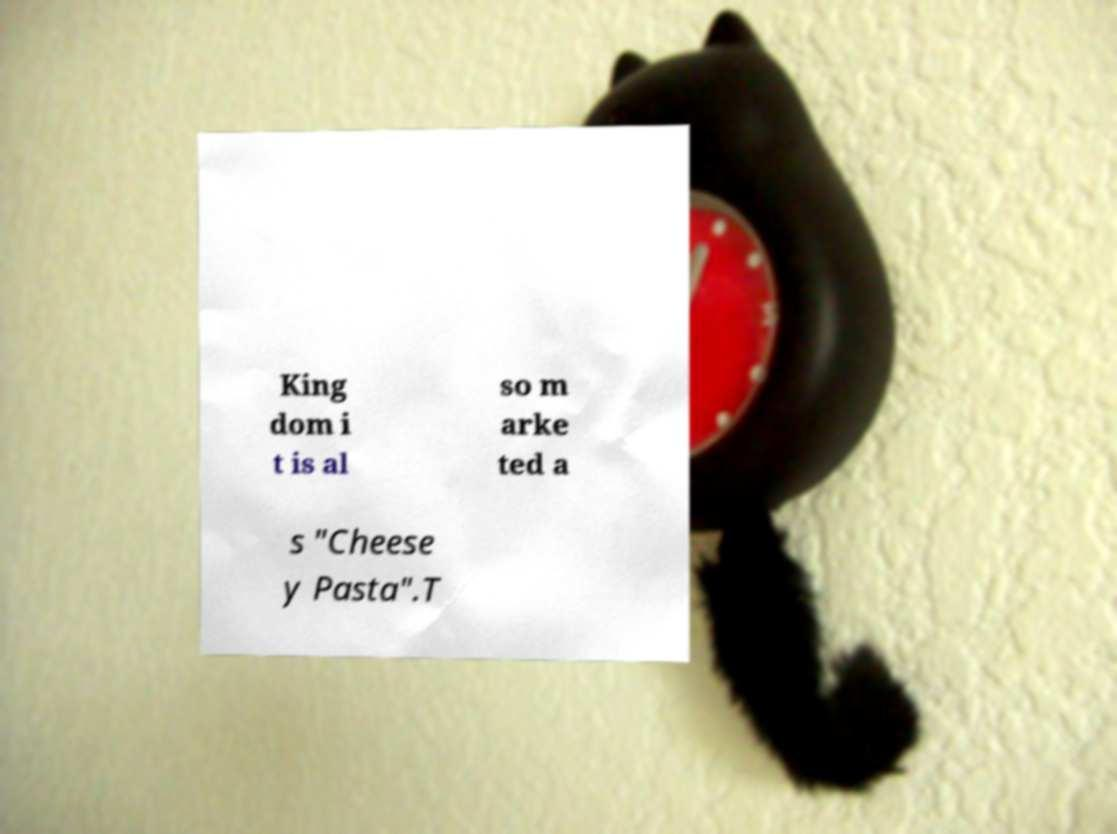For documentation purposes, I need the text within this image transcribed. Could you provide that? King dom i t is al so m arke ted a s "Cheese y Pasta".T 